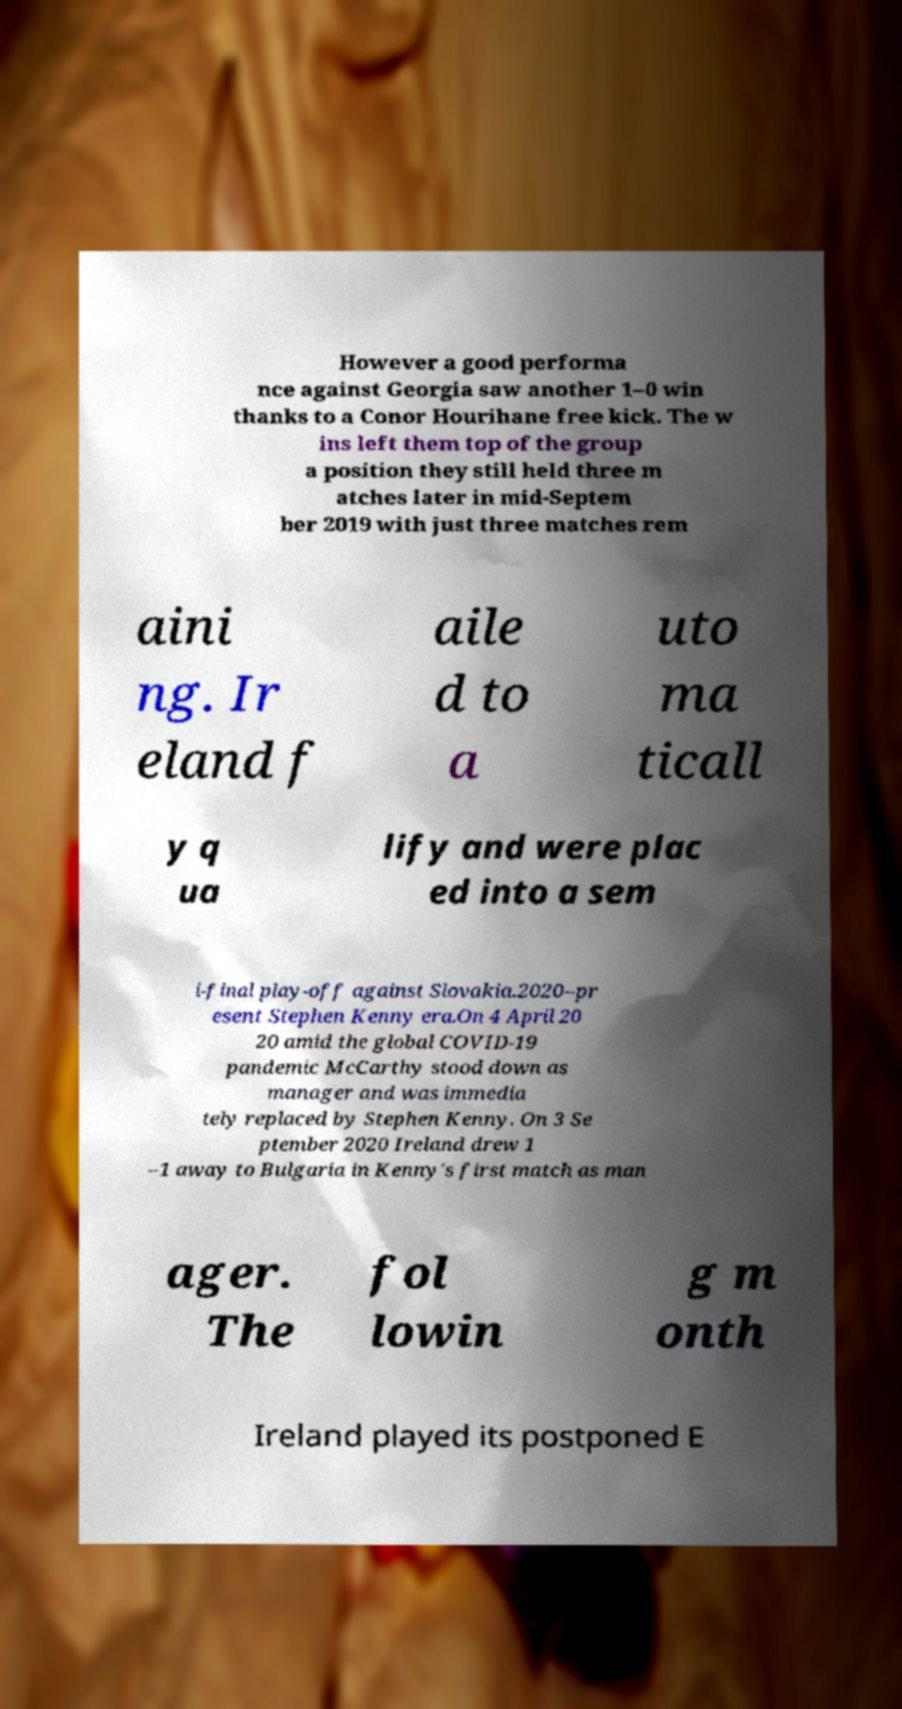There's text embedded in this image that I need extracted. Can you transcribe it verbatim? However a good performa nce against Georgia saw another 1–0 win thanks to a Conor Hourihane free kick. The w ins left them top of the group a position they still held three m atches later in mid-Septem ber 2019 with just three matches rem aini ng. Ir eland f aile d to a uto ma ticall y q ua lify and were plac ed into a sem i-final play-off against Slovakia.2020–pr esent Stephen Kenny era.On 4 April 20 20 amid the global COVID-19 pandemic McCarthy stood down as manager and was immedia tely replaced by Stephen Kenny. On 3 Se ptember 2020 Ireland drew 1 –1 away to Bulgaria in Kenny's first match as man ager. The fol lowin g m onth Ireland played its postponed E 